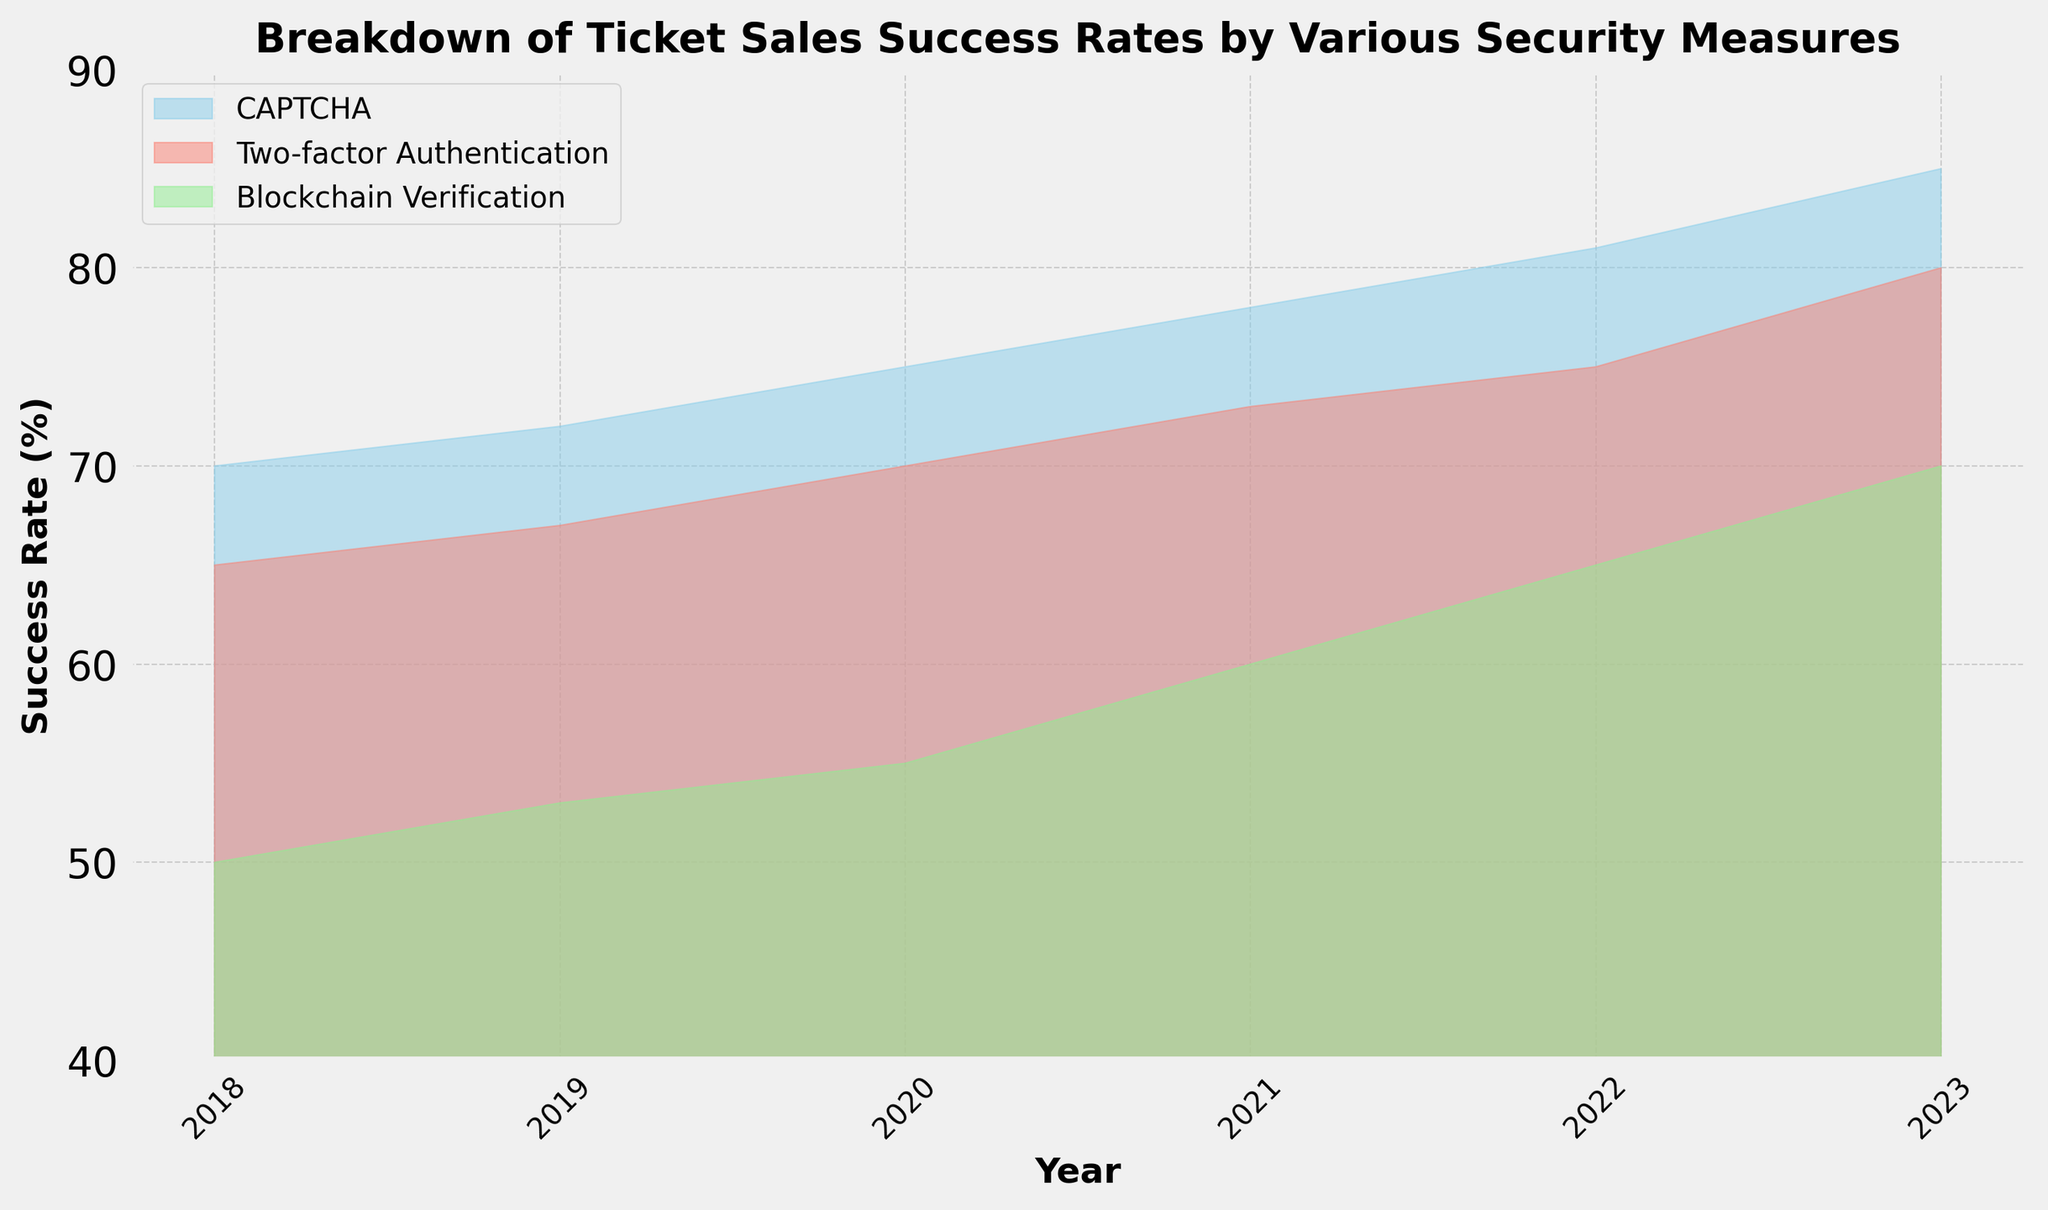How has the success rate of ticket sales using CAPTCHA changed from 2018 to 2023? The success rate for CAPTCHA goes from 70% in 2018 to 85% in 2023.
Answer: Increased by 15% Between 2019 and 2021, which security measure showed the greatest increase in ticket sales success rate? From 2019 to 2021, the success rates improved as follows: CAPTCHA (72% to 78%, an increase of 6%), Two-factor Authentication (67% to 73%, an increase of 6%), and Blockchain Verification (53% to 60%, an increase of 7%).
Answer: Blockchain Verification Which year did Two-factor Authentication surpass CAPTCHA in terms of success rate? Two-factor Authentication has never surpassed CAPTCHA in terms of success rate; CAPTCHA consistently has higher success rates each year.
Answer: Never What is the difference in ticket sales success rates between Blockchain Verification and CAPTCHA in 2022? In 2022, the success rate for Blockchain Verification is 65% and for CAPTCHA it's 81%, the difference is 81% - 65% = 16%.
Answer: 16% Compare the slopes of the success rates for all three security measures from 2020 to 2023; which one increased the sharpest? From 2020 to 2023, the success rates increased as follows: CAPTCHA (75% to 85%, a change of 10%), Two-factor Authentication (70% to 80%, a change of 10%), and Blockchain Verification (55% to 70%, a change of 15%).
Answer: Blockchain Verification Which security measure had the lowest success rate throughout all the shown years? Blockchain Verification consistently had the lowest success rate each year when compared to CAPTCHA and Two-factor Authentication.
Answer: Blockchain Verification In 2020, how much higher was the success rate of Two-factor Authentication compared to Blockchain Verification? The success rate for Two-factor Authentication in 2020 is 70% and for Blockchain Verification it's 55%, the difference is 70% - 55% = 15%.
Answer: 15% How did the success rates for Blockchain Verification and Two-factor Authentication compare in 2020? In 2020, Blockchain Verification had a success rate of 55% while Two-factor Authentication had a success rate of 70%, so Two-factor Authentication was higher by 15%.
Answer: Two-factor Authentication was higher by 15% What general trend can be observed for ticket sales success rates over recent years? All security measures show an upward trend in success rates over the years from 2018 to 2023.
Answer: Upward trend for all What is the average success rate of CAPTCHA from 2018 to 2023? The success rates for CAPTCHA over the years are 70%, 72%, 75%, 78%, 81%, and 85%. Adding these up (70 + 72 + 75 + 78 + 81 + 85 = 461) and dividing by 6 gives an average of 461/6 ≈ 76.83%.
Answer: 76.83% 